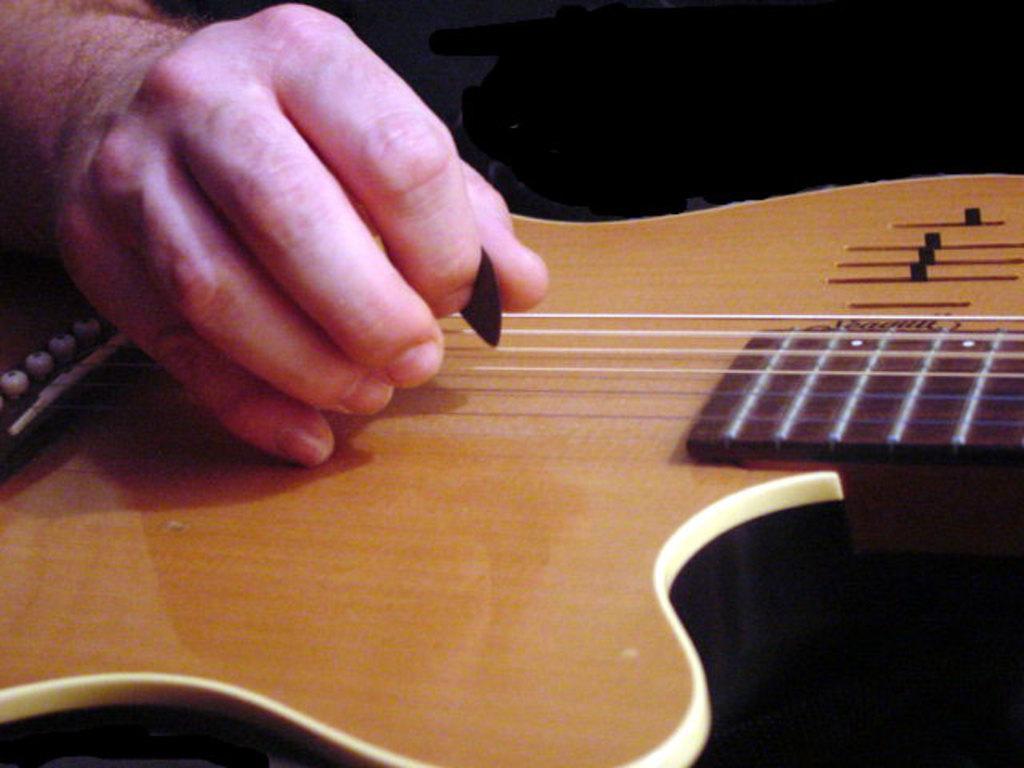Please provide a concise description of this image. In this image there is a person playing a guitar. 